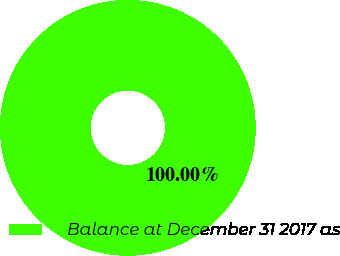Convert chart to OTSL. <chart><loc_0><loc_0><loc_500><loc_500><pie_chart><fcel>Balance at December 31 2017 as<nl><fcel>100.0%<nl></chart> 